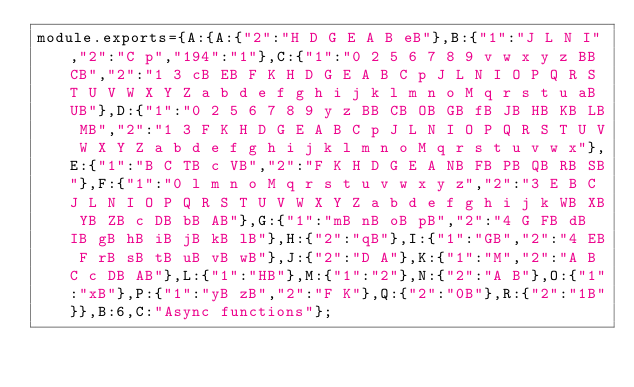Convert code to text. <code><loc_0><loc_0><loc_500><loc_500><_JavaScript_>module.exports={A:{A:{"2":"H D G E A B eB"},B:{"1":"J L N I","2":"C p","194":"1"},C:{"1":"0 2 5 6 7 8 9 v w x y z BB CB","2":"1 3 cB EB F K H D G E A B C p J L N I O P Q R S T U V W X Y Z a b d e f g h i j k l m n o M q r s t u aB UB"},D:{"1":"0 2 5 6 7 8 9 y z BB CB OB GB fB JB HB KB LB MB","2":"1 3 F K H D G E A B C p J L N I O P Q R S T U V W X Y Z a b d e f g h i j k l m n o M q r s t u v w x"},E:{"1":"B C TB c VB","2":"F K H D G E A NB FB PB QB RB SB"},F:{"1":"0 l m n o M q r s t u v w x y z","2":"3 E B C J L N I O P Q R S T U V W X Y Z a b d e f g h i j k WB XB YB ZB c DB bB AB"},G:{"1":"mB nB oB pB","2":"4 G FB dB IB gB hB iB jB kB lB"},H:{"2":"qB"},I:{"1":"GB","2":"4 EB F rB sB tB uB vB wB"},J:{"2":"D A"},K:{"1":"M","2":"A B C c DB AB"},L:{"1":"HB"},M:{"1":"2"},N:{"2":"A B"},O:{"1":"xB"},P:{"1":"yB zB","2":"F K"},Q:{"2":"0B"},R:{"2":"1B"}},B:6,C:"Async functions"};
</code> 